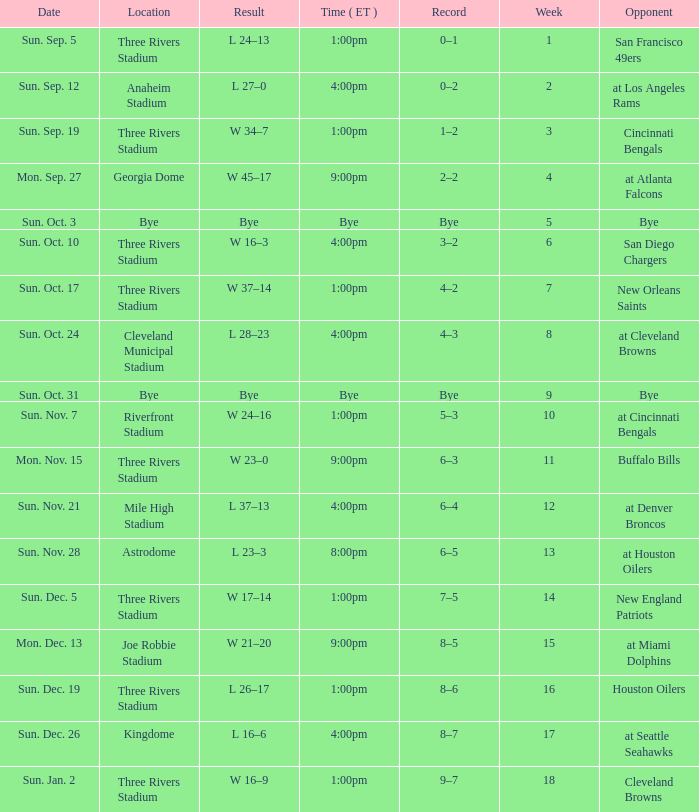What is the earliest week that shows a record of 8–5? 15.0. 